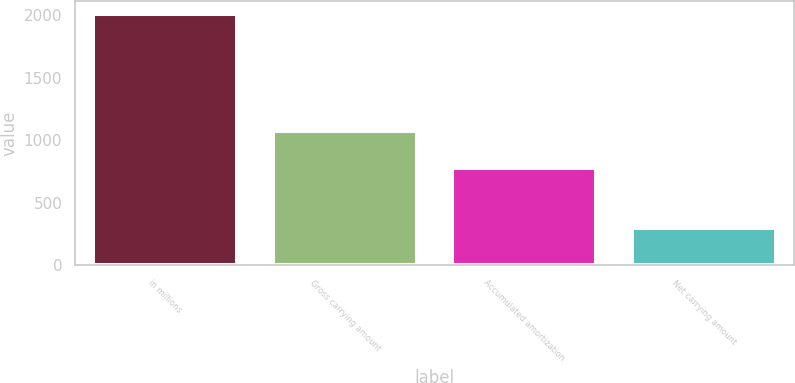<chart> <loc_0><loc_0><loc_500><loc_500><bar_chart><fcel>in millions<fcel>Gross carrying amount<fcel>Accumulated amortization<fcel>Net carrying amount<nl><fcel>2015<fcel>1072<fcel>777<fcel>295<nl></chart> 